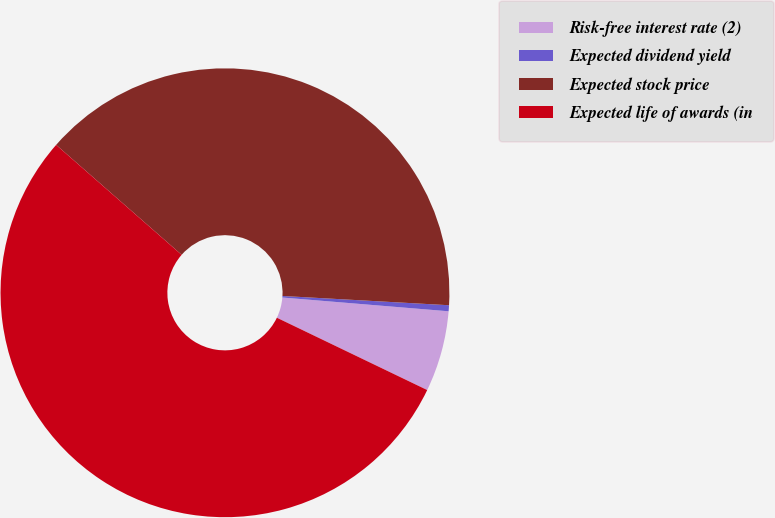<chart> <loc_0><loc_0><loc_500><loc_500><pie_chart><fcel>Risk-free interest rate (2)<fcel>Expected dividend yield<fcel>Expected stock price<fcel>Expected life of awards (in<nl><fcel>5.82%<fcel>0.43%<fcel>39.43%<fcel>54.31%<nl></chart> 